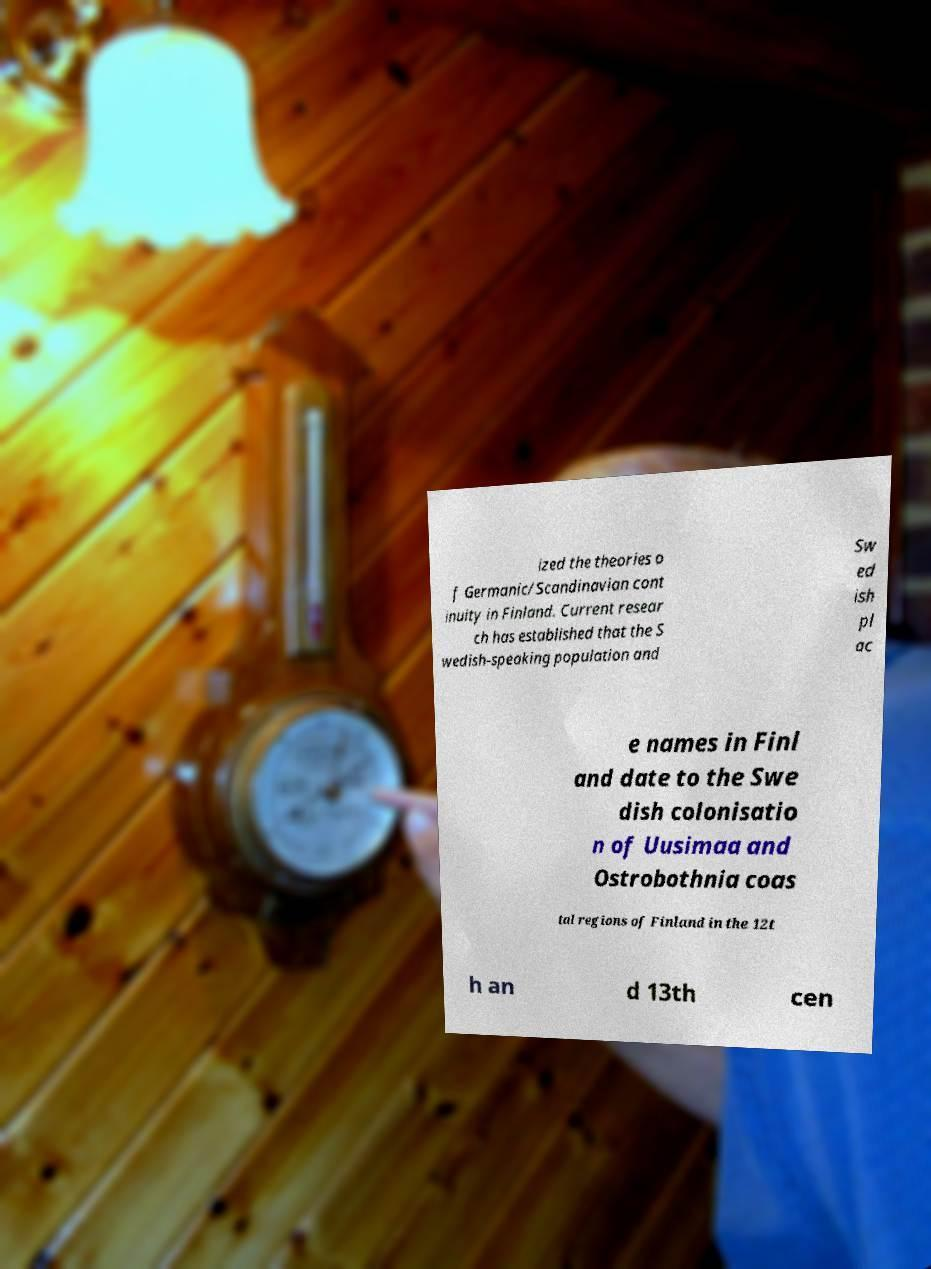There's text embedded in this image that I need extracted. Can you transcribe it verbatim? ized the theories o f Germanic/Scandinavian cont inuity in Finland. Current resear ch has established that the S wedish-speaking population and Sw ed ish pl ac e names in Finl and date to the Swe dish colonisatio n of Uusimaa and Ostrobothnia coas tal regions of Finland in the 12t h an d 13th cen 